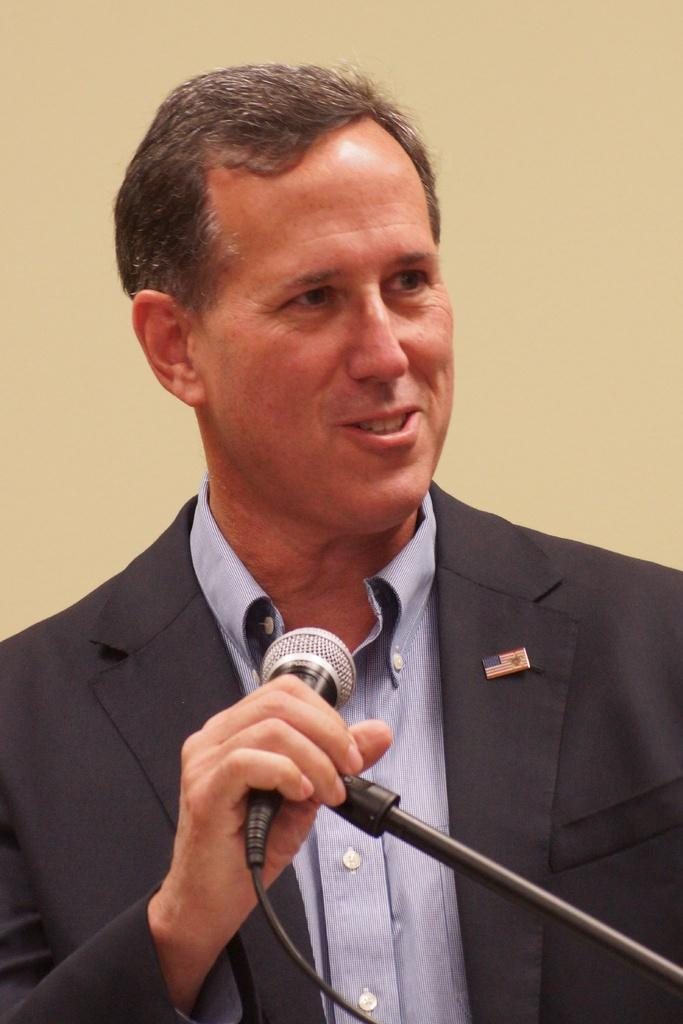Who is the main subject in the image? There is a man in the image. What is the man wearing? The man is wearing a blazer. What is the man holding in the image? The man is holding a microphone. What expression does the man have on his face? The man is smiling. What type of marble is the man using to create his speech in the image? There is no marble present in the image, and the man is not creating a speech using any materials. 